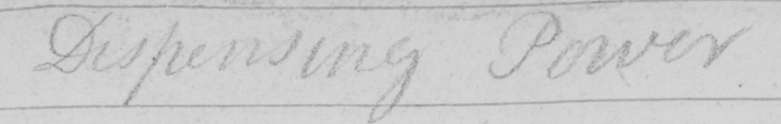Can you tell me what this handwritten text says? Dispensing Power 